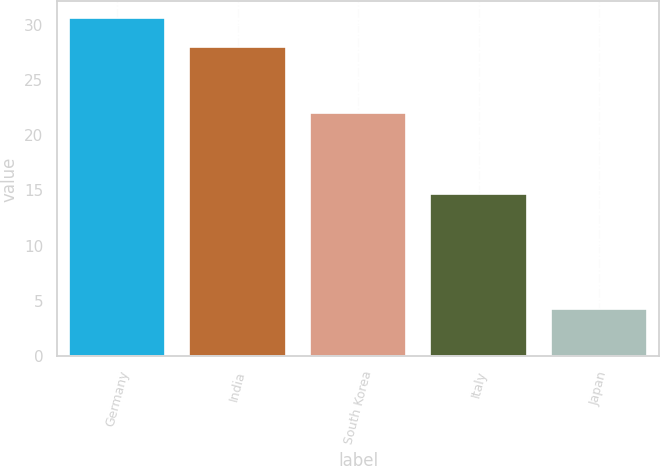Convert chart. <chart><loc_0><loc_0><loc_500><loc_500><bar_chart><fcel>Germany<fcel>India<fcel>South Korea<fcel>Italy<fcel>Japan<nl><fcel>30.56<fcel>28<fcel>22<fcel>14.7<fcel>4.3<nl></chart> 